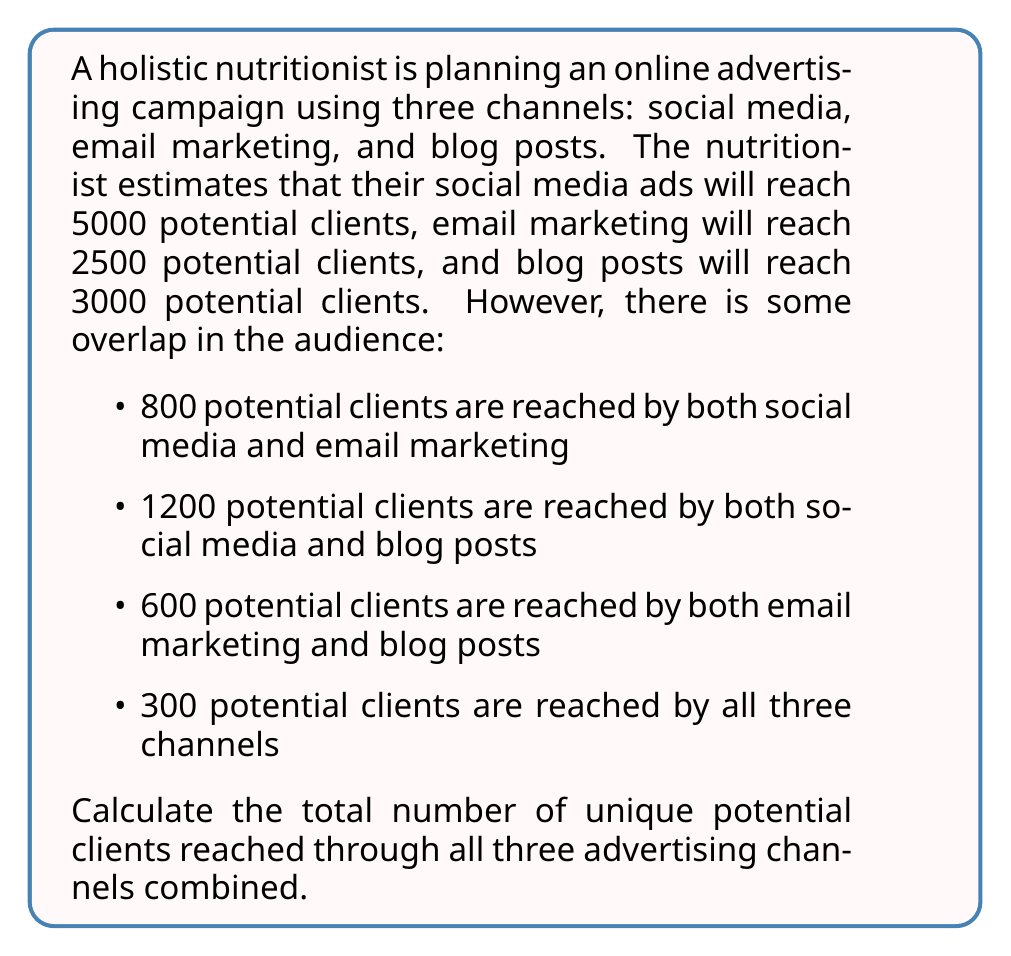Could you help me with this problem? To solve this problem, we can use the principle of inclusion-exclusion. Let's define our sets:

$A$: Potential clients reached by social media
$B$: Potential clients reached by email marketing
$C$: Potential clients reached by blog posts

We're given:
$|A| = 5000$
$|B| = 2500$
$|C| = 3000$
$|A \cap B| = 800$
$|A \cap C| = 1200$
$|B \cap C| = 600$
$|A \cap B \cap C| = 300$

The formula for the union of three sets is:

$$|A \cup B \cup C| = |A| + |B| + |C| - |A \cap B| - |A \cap C| - |B \cap C| + |A \cap B \cap C|$$

Let's substitute our values:

$$\begin{align*}
|A \cup B \cup C| &= 5000 + 2500 + 3000 - 800 - 1200 - 600 + 300 \\
&= 10500 - 2600 + 300 \\
&= 8200
\end{align*}$$
Answer: The total number of unique potential clients reached through all three advertising channels combined is 8200. 